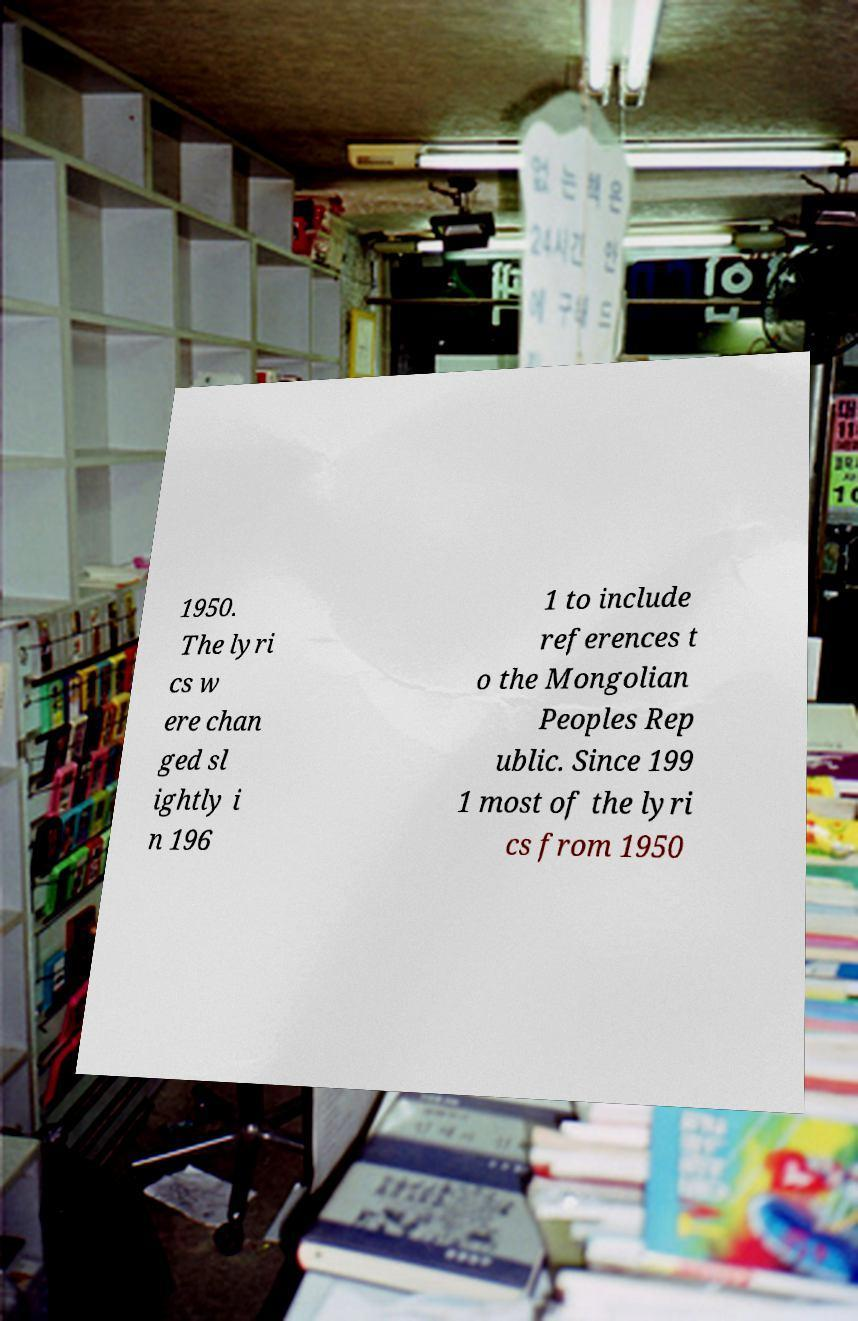Please read and relay the text visible in this image. What does it say? 1950. The lyri cs w ere chan ged sl ightly i n 196 1 to include references t o the Mongolian Peoples Rep ublic. Since 199 1 most of the lyri cs from 1950 